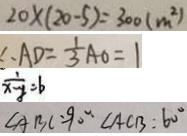Convert formula to latex. <formula><loc_0><loc_0><loc_500><loc_500>2 0 \times ( 2 0 - 5 ) = 3 0 0 ( m ^ { 2 } ) 
 \therefore A D = \frac { 1 } { 3 } A O = 1 
 \frac { 1 } { x - y } = b 
 \angle A B C = 9 0 ^ { \circ } \angle A C B : 6 0 ^ { \circ }</formula> 